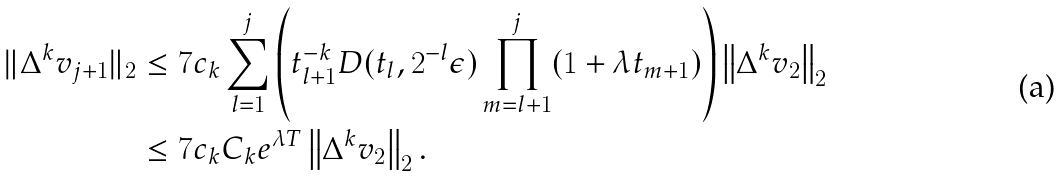Convert formula to latex. <formula><loc_0><loc_0><loc_500><loc_500>\| \Delta ^ { k } v _ { j + 1 } \| _ { 2 } & \leq 7 c _ { k } \sum _ { l = 1 } ^ { j } \left ( t _ { l + 1 } ^ { - k } D ( t _ { l } , 2 ^ { - l } \epsilon ) \prod _ { m = l + 1 } ^ { j } ( 1 + \lambda t _ { m + 1 } ) \right ) \left \| \Delta ^ { k } v _ { 2 } \right \| _ { 2 } \\ & \leq 7 c _ { k } C _ { k } e ^ { \lambda T } \left \| \Delta ^ { k } v _ { 2 } \right \| _ { 2 } .</formula> 